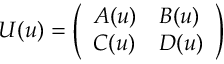<formula> <loc_0><loc_0><loc_500><loc_500>U ( u ) = \left ( \begin{array} { l l } { A ( u ) } & { B ( u ) } \\ { C ( u ) } & { D ( u ) } \end{array} \right )</formula> 